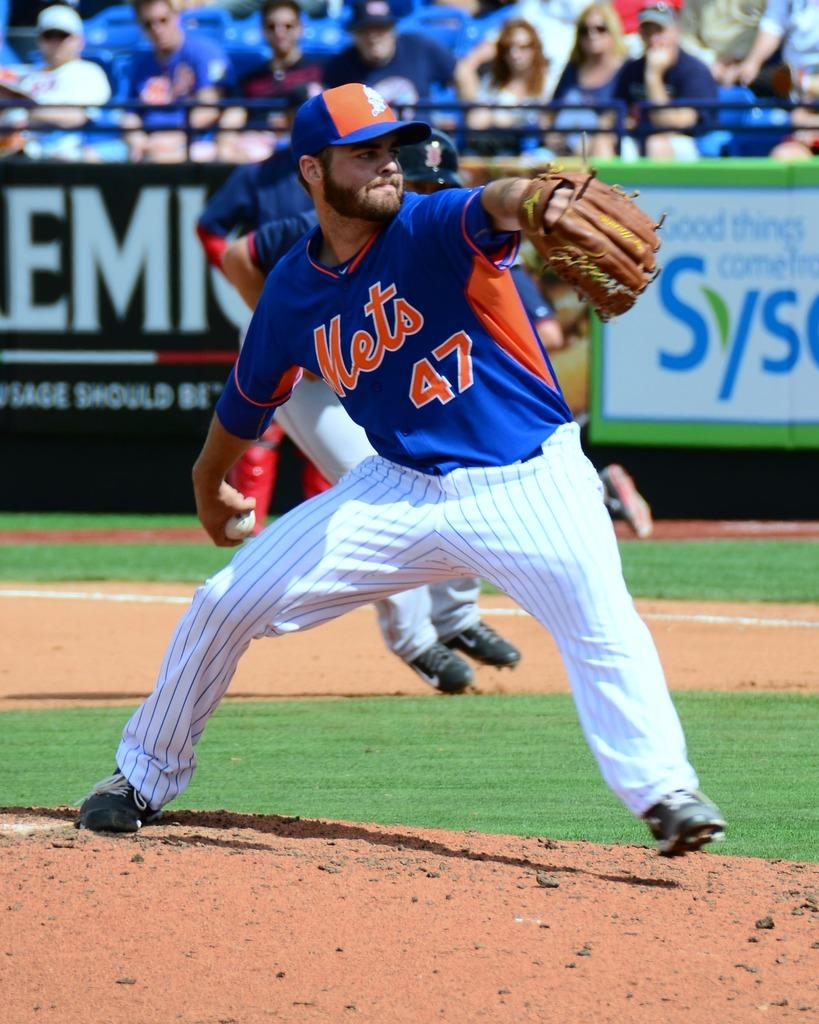<image>
Describe the image concisely. The pitcher on the mound play for the Mets. 